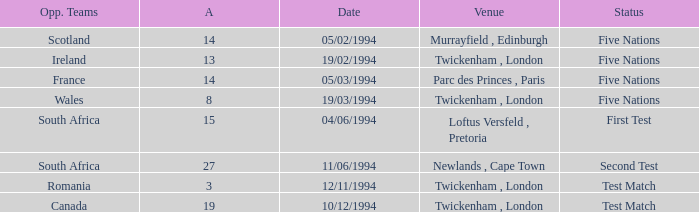Which venue has more than 19 against? Newlands , Cape Town. 